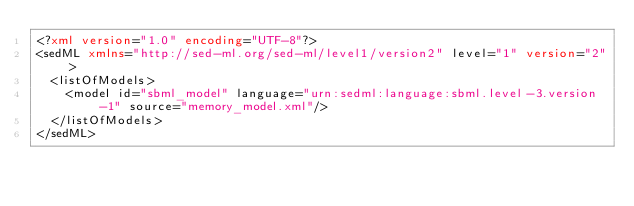<code> <loc_0><loc_0><loc_500><loc_500><_XML_><?xml version="1.0" encoding="UTF-8"?>
<sedML xmlns="http://sed-ml.org/sed-ml/level1/version2" level="1" version="2">
  <listOfModels>
    <model id="sbml_model" language="urn:sedml:language:sbml.level-3.version-1" source="memory_model.xml"/>
  </listOfModels>
</sedML>
</code> 